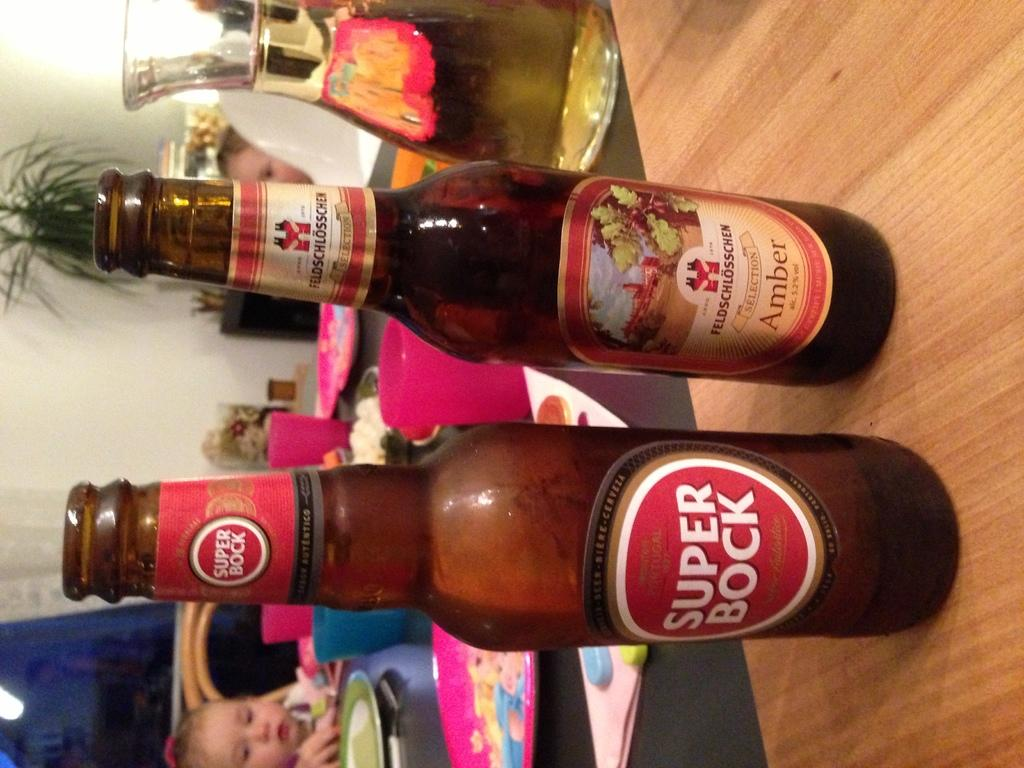<image>
Describe the image concisely. A bottle of Super Bock beer sits next to a bottle of Feldschlosschen beer 